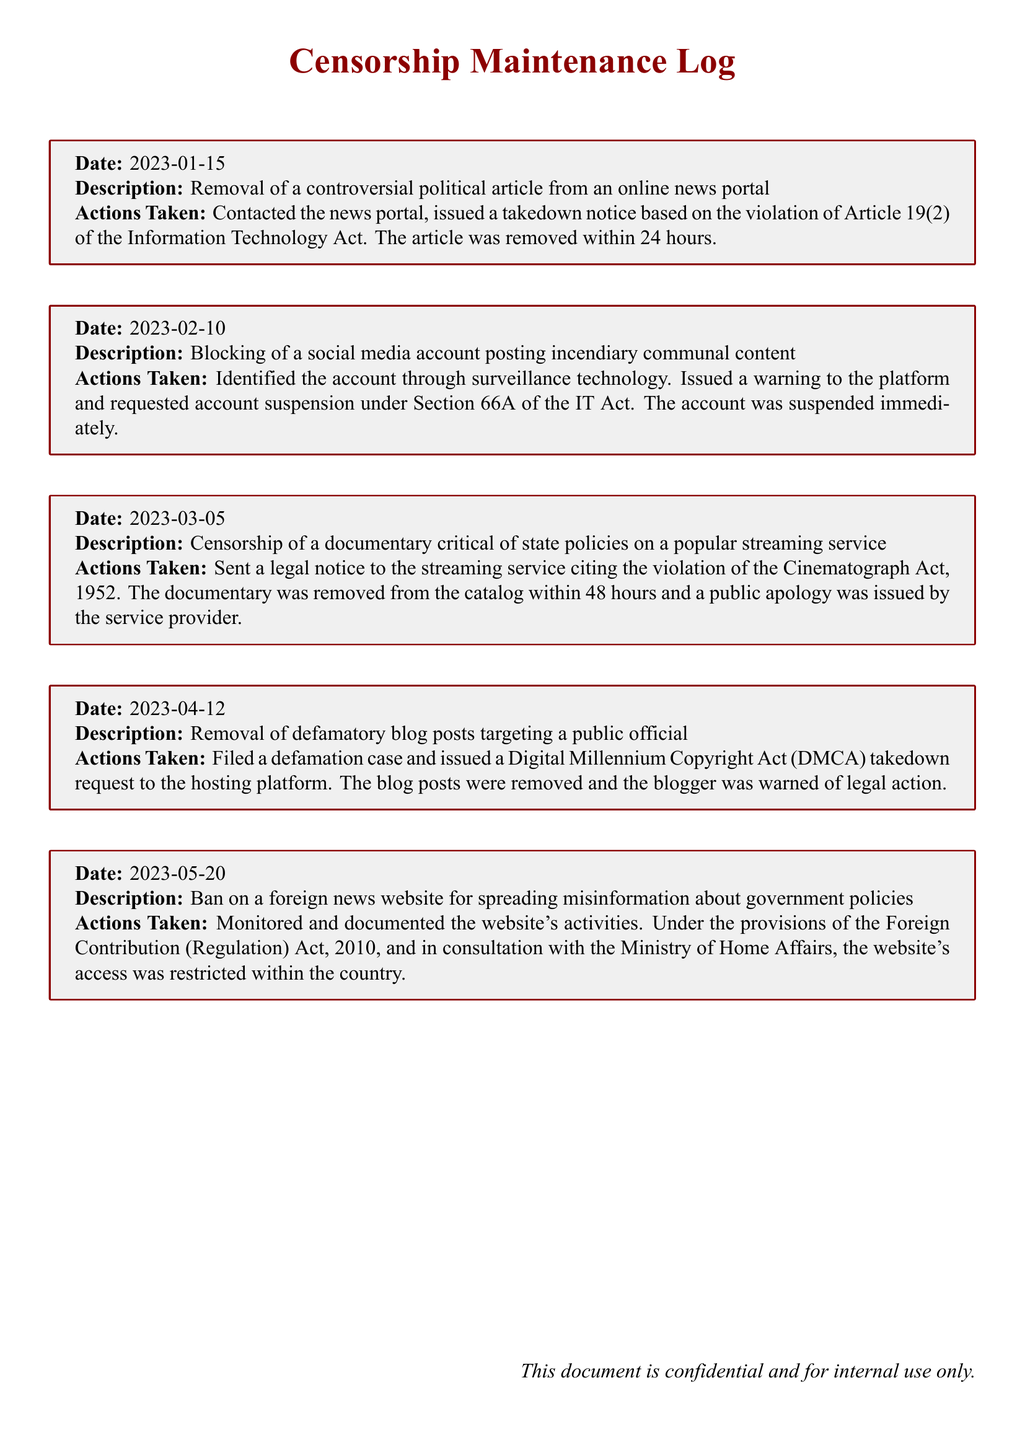What is the date of the first incident? The first incident is recorded on January 15, 2023.
Answer: January 15, 2023 What article was removed on January 15, 2023? The article removed was controversial political article from an online news portal.
Answer: Controversial political article How long did it take to remove the article mentioned in the first incident? The article was removed within 24 hours of the takedown notice.
Answer: 24 hours Under which act was the social media account blocked? The social media account was blocked under Section 66A of the IT Act.
Answer: Section 66A of the IT Act What action was taken for the documentary censorship on March 5, 2023? A legal notice was sent to the streaming service citing the violation of the Cinematograph Act, 1952.
Answer: Sent a legal notice How many days did it take for the documentary to be removed after the notice? The documentary was removed within 48 hours after the notice was sent.
Answer: 48 hours What incident occurred on May 20, 2023? A foreign news website was banned for spreading misinformation about government policies.
Answer: Ban on a foreign news website What law was cited for the restriction of the website's access? The restriction was made under the provisions of the Foreign Contribution (Regulation) Act, 2010.
Answer: Foreign Contribution (Regulation) Act, 2010 What type of content was targeted in the April 12 incident? The content targeted was defamatory blog posts against a public official.
Answer: Defamatory blog posts What was issued to the hosting platform for the removal of blog posts? A Digital Millennium Copyright Act (DMCA) takedown request was issued to the hosting platform.
Answer: DMCA takedown request 